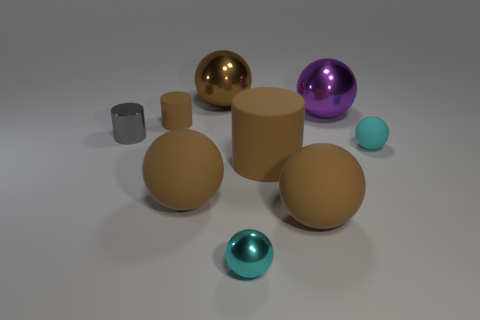Subtract all purple cylinders. How many brown balls are left? 3 Subtract all large purple metal spheres. How many spheres are left? 5 Subtract all brown balls. How many balls are left? 3 Subtract all cylinders. How many objects are left? 6 Subtract all purple spheres. Subtract all red blocks. How many spheres are left? 5 Add 1 shiny cylinders. How many shiny cylinders are left? 2 Add 8 cyan objects. How many cyan objects exist? 10 Subtract 0 red blocks. How many objects are left? 9 Subtract all brown things. Subtract all big rubber cylinders. How many objects are left? 3 